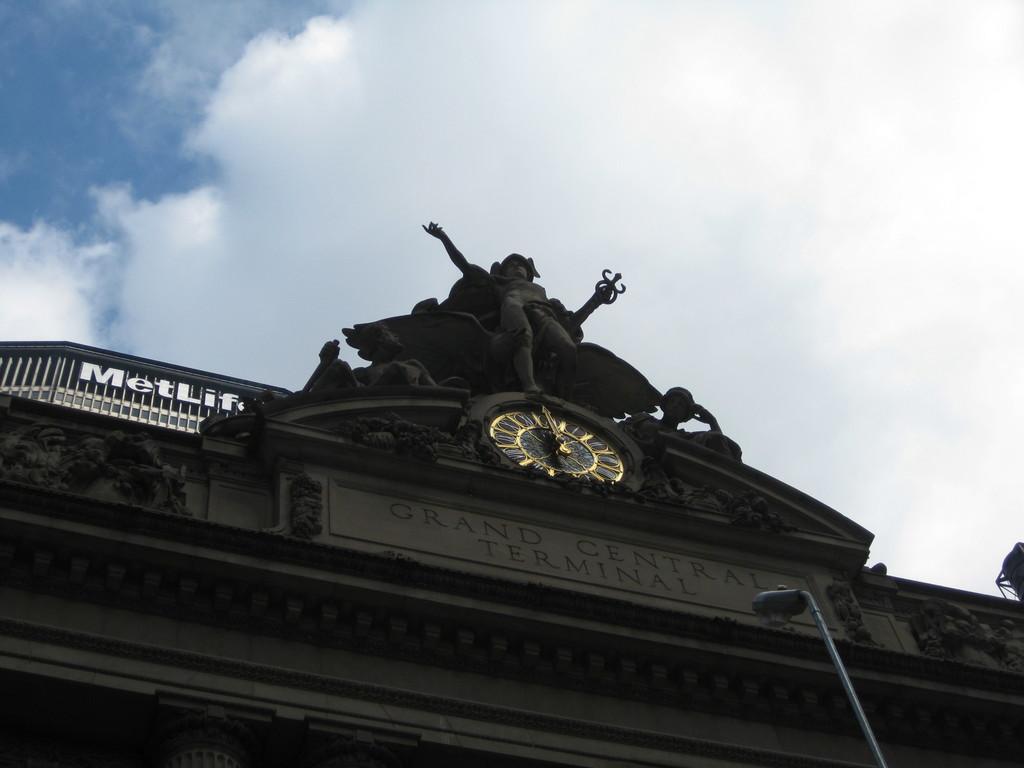Where is this terminal?
Offer a very short reply. Grand central. What company is in the background?
Your response must be concise. Metlife. 